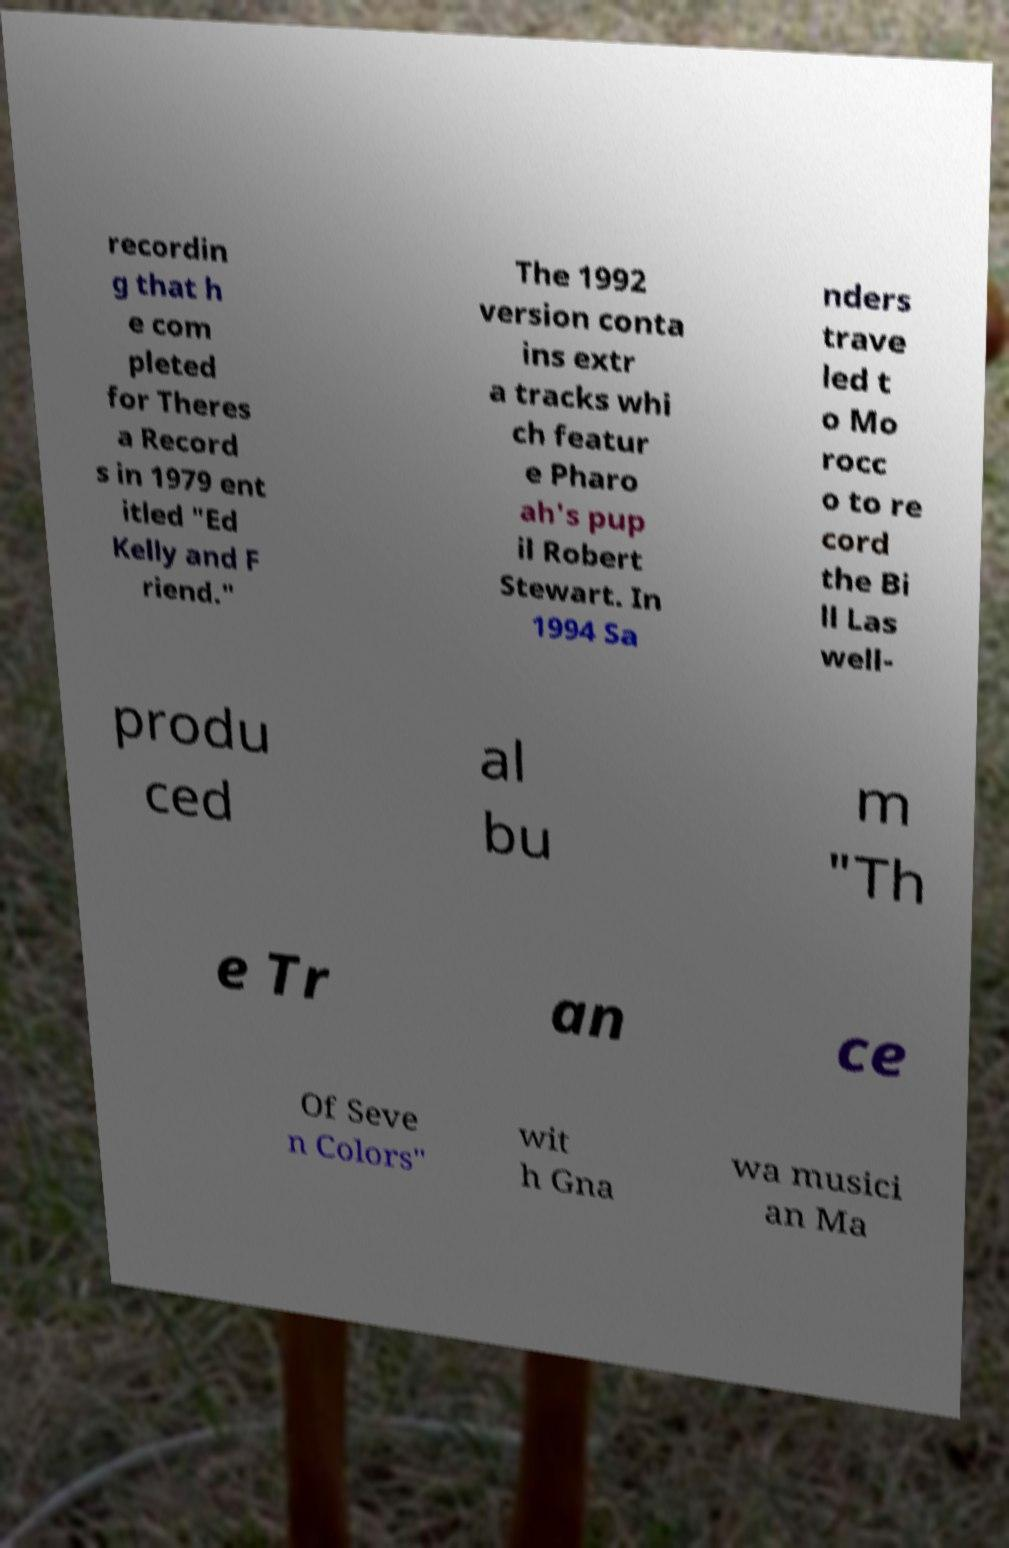Can you read and provide the text displayed in the image?This photo seems to have some interesting text. Can you extract and type it out for me? recordin g that h e com pleted for Theres a Record s in 1979 ent itled "Ed Kelly and F riend." The 1992 version conta ins extr a tracks whi ch featur e Pharo ah's pup il Robert Stewart. In 1994 Sa nders trave led t o Mo rocc o to re cord the Bi ll Las well- produ ced al bu m "Th e Tr an ce Of Seve n Colors" wit h Gna wa musici an Ma 